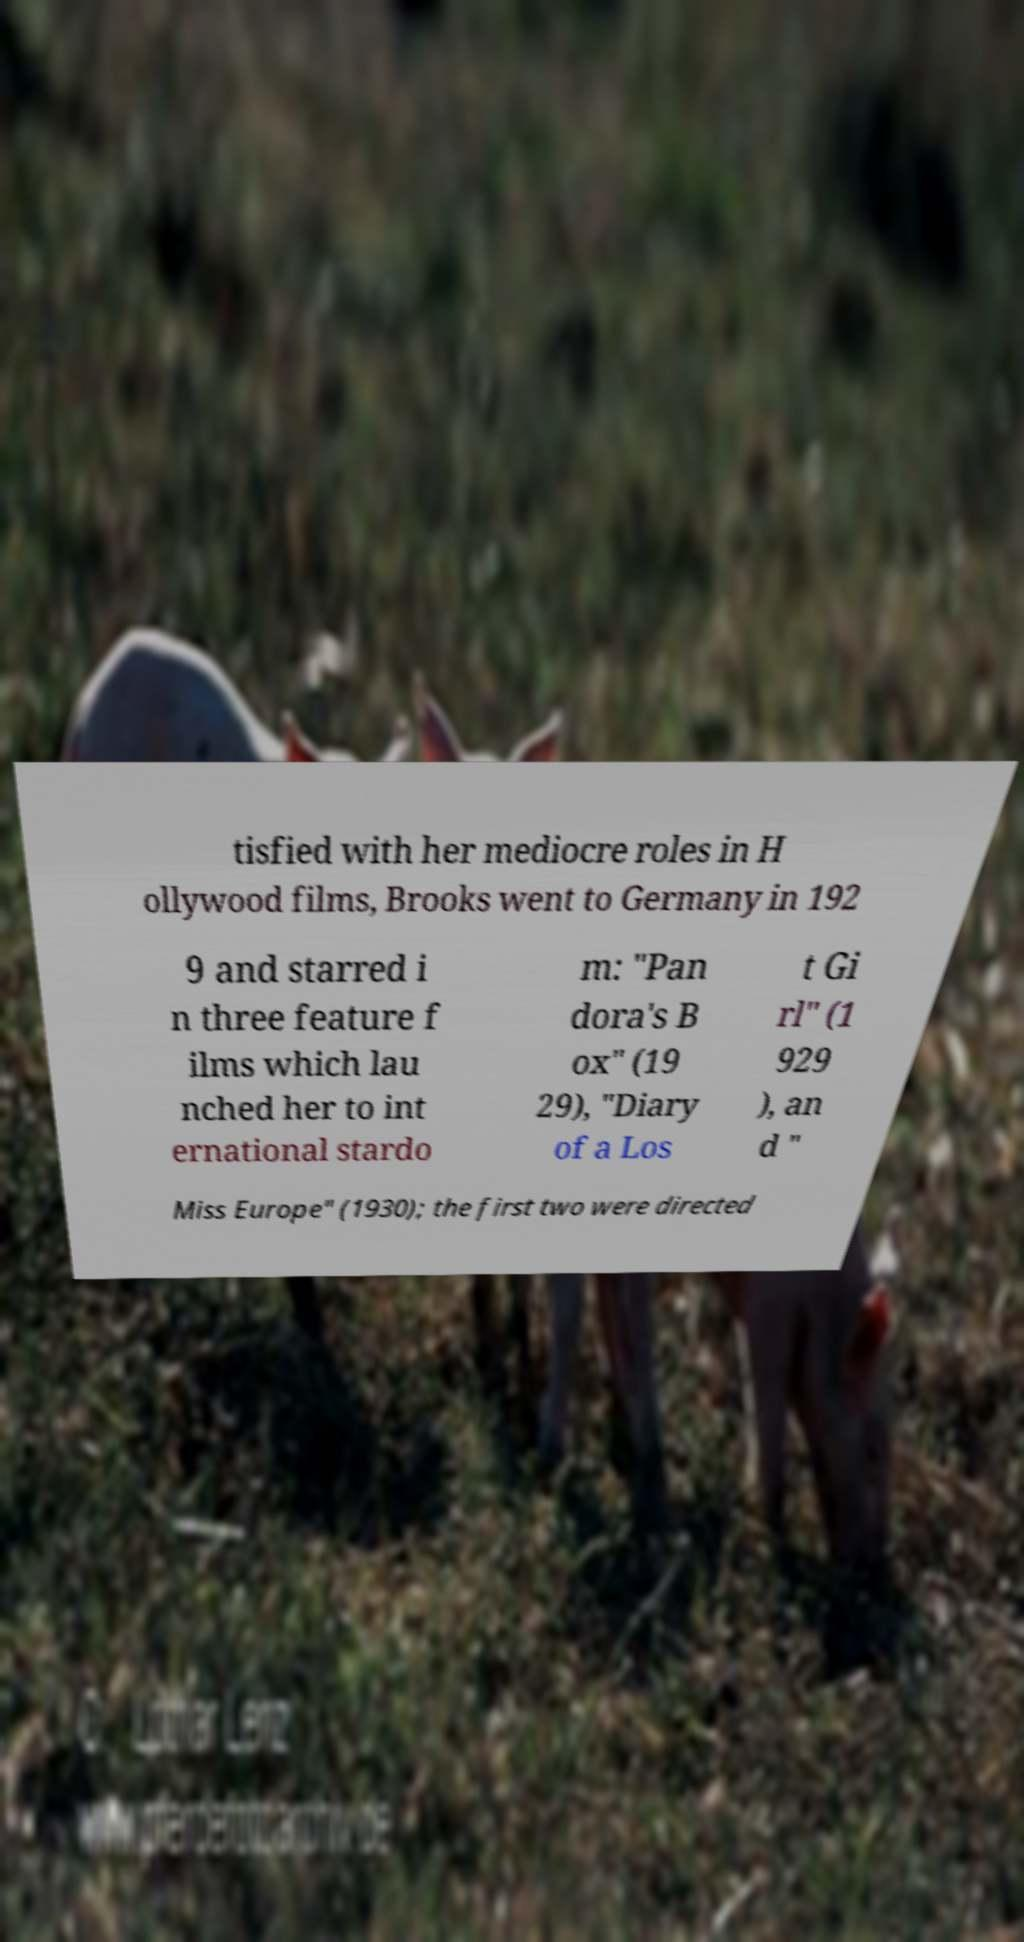Could you extract and type out the text from this image? tisfied with her mediocre roles in H ollywood films, Brooks went to Germany in 192 9 and starred i n three feature f ilms which lau nched her to int ernational stardo m: "Pan dora's B ox" (19 29), "Diary of a Los t Gi rl" (1 929 ), an d " Miss Europe" (1930); the first two were directed 